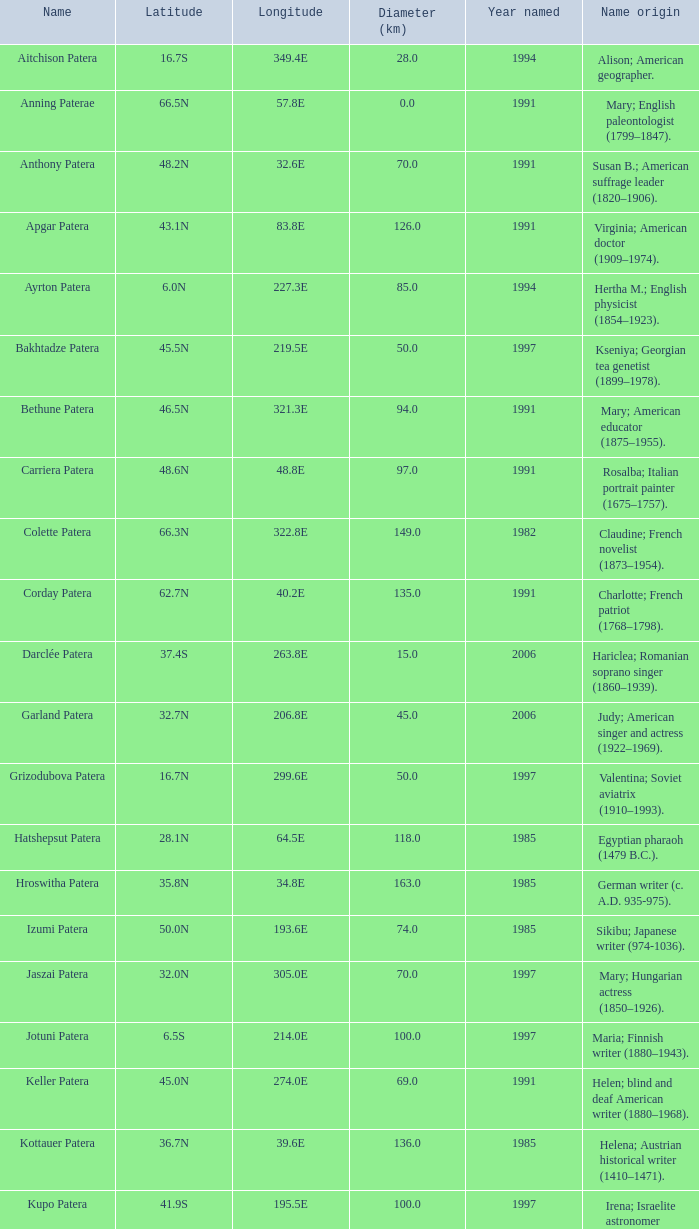In what year was the feature at a 33.3S latitude named?  2000.0. 